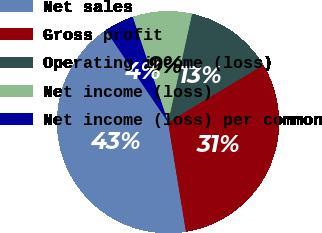Convert chart. <chart><loc_0><loc_0><loc_500><loc_500><pie_chart><fcel>Net sales<fcel>Gross profit<fcel>Operating income (loss)<fcel>Net income (loss)<fcel>Net income (loss) per common<nl><fcel>43.1%<fcel>31.03%<fcel>12.93%<fcel>8.62%<fcel>4.31%<nl></chart> 